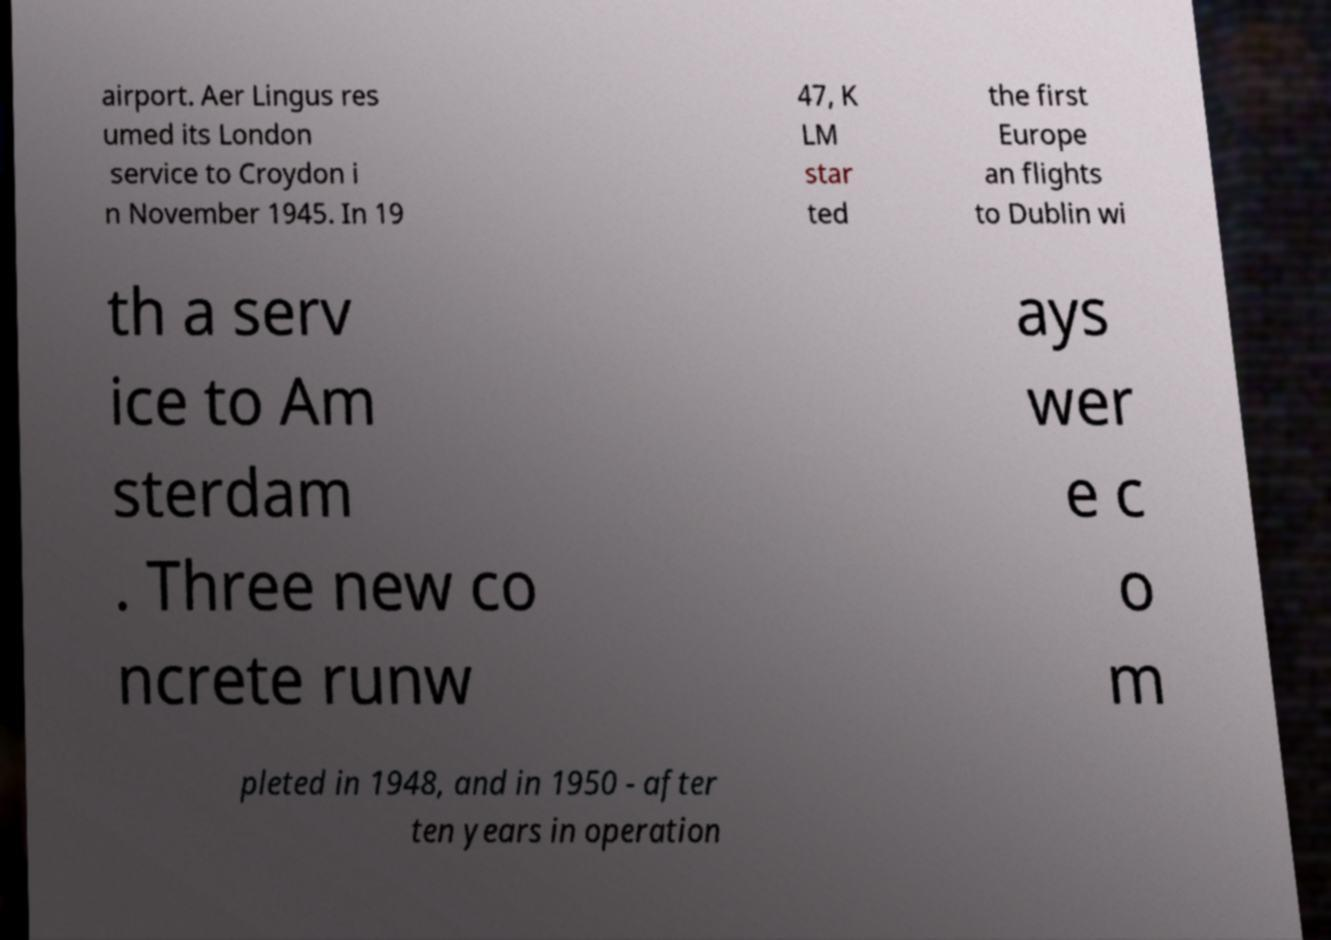I need the written content from this picture converted into text. Can you do that? airport. Aer Lingus res umed its London service to Croydon i n November 1945. In 19 47, K LM star ted the first Europe an flights to Dublin wi th a serv ice to Am sterdam . Three new co ncrete runw ays wer e c o m pleted in 1948, and in 1950 - after ten years in operation 